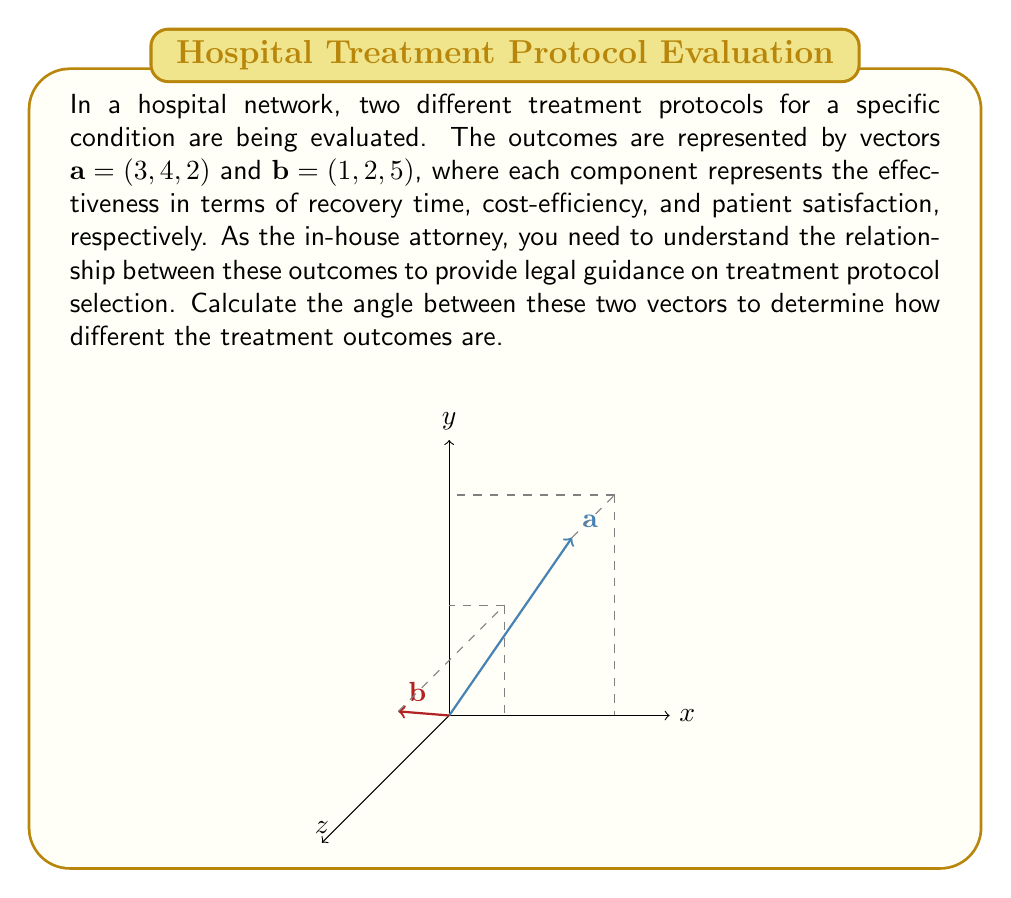Give your solution to this math problem. To find the angle between two vectors, we can use the dot product formula:

$$\cos \theta = \frac{\mathbf{a} \cdot \mathbf{b}}{|\mathbf{a}||\mathbf{b}|}$$

Step 1: Calculate the dot product $\mathbf{a} \cdot \mathbf{b}$
$$\mathbf{a} \cdot \mathbf{b} = (3)(1) + (4)(2) + (2)(5) = 3 + 8 + 10 = 21$$

Step 2: Calculate the magnitudes of vectors $\mathbf{a}$ and $\mathbf{b}$
$$|\mathbf{a}| = \sqrt{3^2 + 4^2 + 2^2} = \sqrt{9 + 16 + 4} = \sqrt{29}$$
$$|\mathbf{b}| = \sqrt{1^2 + 2^2 + 5^2} = \sqrt{1 + 4 + 25} = \sqrt{30}$$

Step 3: Apply the dot product formula
$$\cos \theta = \frac{21}{\sqrt{29}\sqrt{30}}$$

Step 4: Take the inverse cosine (arccos) of both sides
$$\theta = \arccos\left(\frac{21}{\sqrt{29}\sqrt{30}}\right)$$

Step 5: Calculate the final result
$$\theta \approx 0.5095 \text{ radians} \approx 29.21\text{°}$$
Answer: $29.21\text{°}$ 